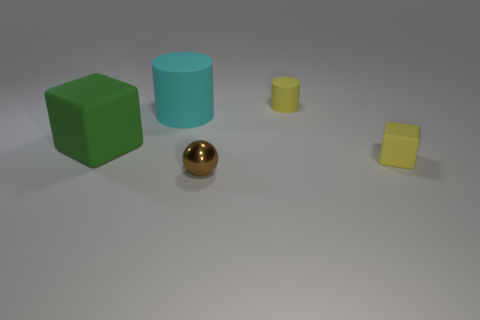Add 3 rubber objects. How many objects exist? 8 Subtract all green blocks. How many blocks are left? 1 Add 4 big objects. How many big objects exist? 6 Subtract 0 purple cubes. How many objects are left? 5 Subtract all spheres. How many objects are left? 4 Subtract 1 balls. How many balls are left? 0 Subtract all red cubes. Subtract all purple balls. How many cubes are left? 2 Subtract all brown balls. How many cyan blocks are left? 0 Subtract all matte cylinders. Subtract all large red matte cylinders. How many objects are left? 3 Add 2 tiny rubber cylinders. How many tiny rubber cylinders are left? 3 